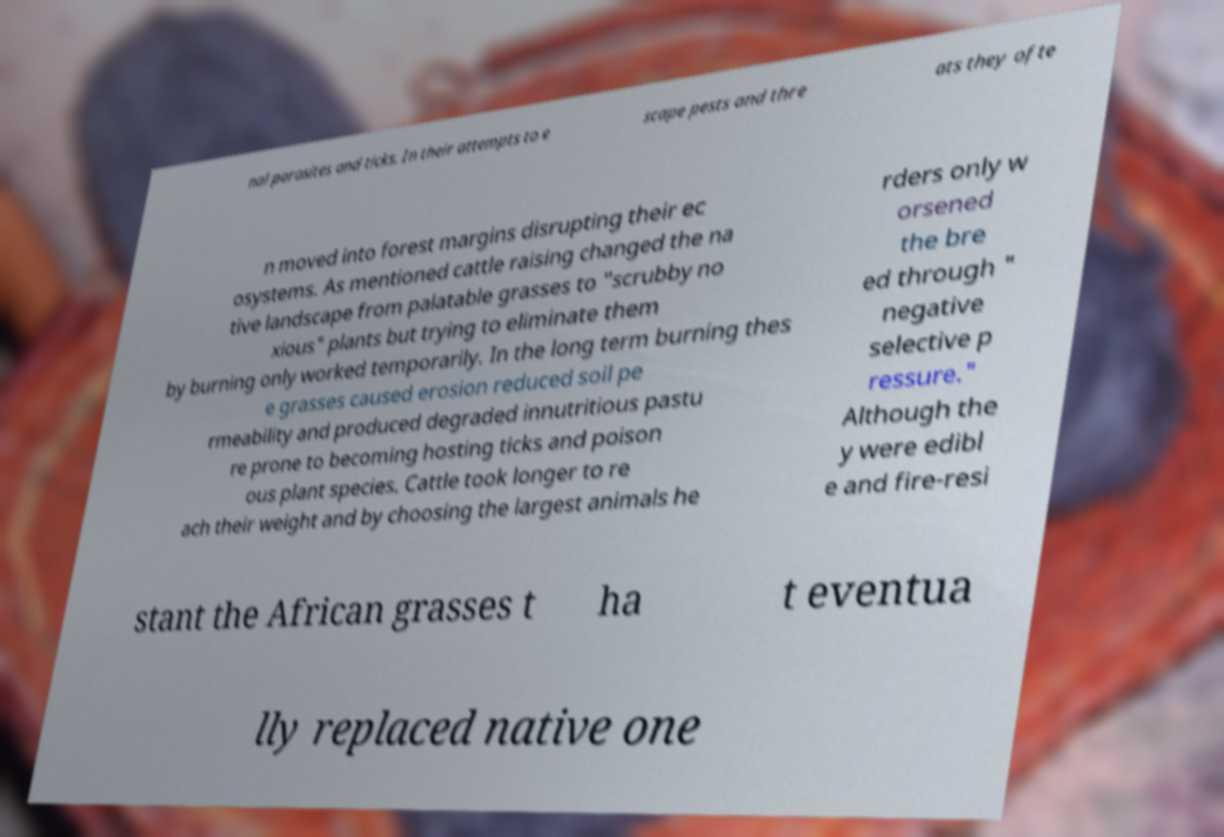Could you assist in decoding the text presented in this image and type it out clearly? nal parasites and ticks. In their attempts to e scape pests and thre ats they ofte n moved into forest margins disrupting their ec osystems. As mentioned cattle raising changed the na tive landscape from palatable grasses to "scrubby no xious" plants but trying to eliminate them by burning only worked temporarily. In the long term burning thes e grasses caused erosion reduced soil pe rmeability and produced degraded innutritious pastu re prone to becoming hosting ticks and poison ous plant species. Cattle took longer to re ach their weight and by choosing the largest animals he rders only w orsened the bre ed through " negative selective p ressure." Although the y were edibl e and fire-resi stant the African grasses t ha t eventua lly replaced native one 